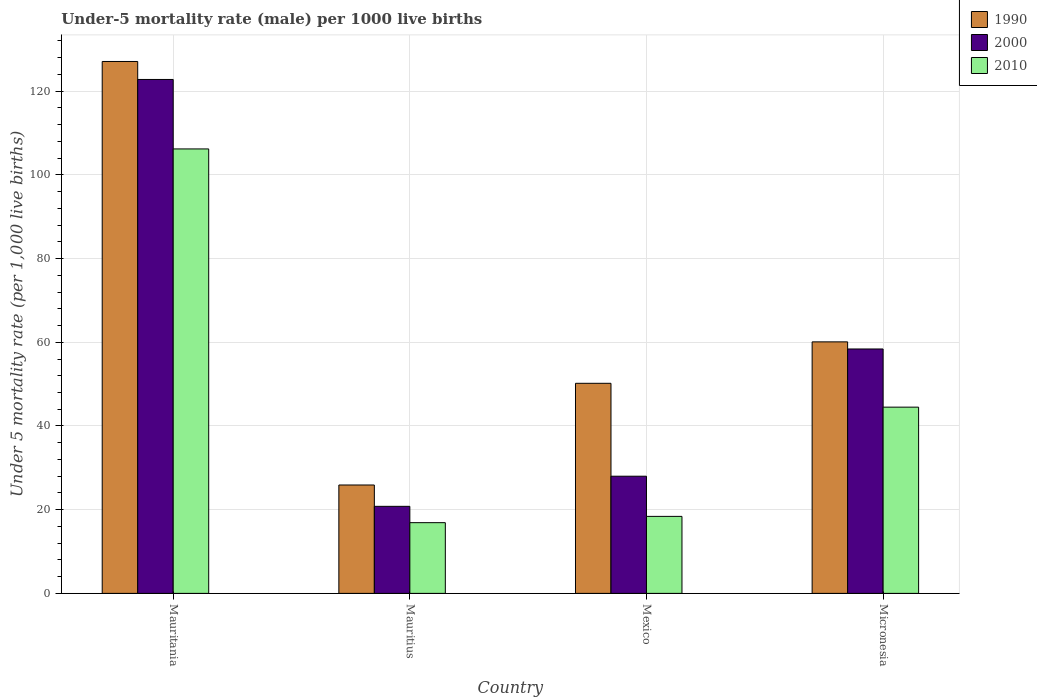Are the number of bars on each tick of the X-axis equal?
Offer a terse response. Yes. How many bars are there on the 2nd tick from the left?
Give a very brief answer. 3. How many bars are there on the 2nd tick from the right?
Ensure brevity in your answer.  3. What is the label of the 4th group of bars from the left?
Your answer should be very brief. Micronesia. In how many cases, is the number of bars for a given country not equal to the number of legend labels?
Provide a succinct answer. 0. What is the under-five mortality rate in 2000 in Micronesia?
Keep it short and to the point. 58.4. Across all countries, what is the maximum under-five mortality rate in 1990?
Offer a terse response. 127.1. Across all countries, what is the minimum under-five mortality rate in 1990?
Your response must be concise. 25.9. In which country was the under-five mortality rate in 1990 maximum?
Provide a succinct answer. Mauritania. In which country was the under-five mortality rate in 2000 minimum?
Make the answer very short. Mauritius. What is the total under-five mortality rate in 1990 in the graph?
Your answer should be very brief. 263.3. What is the difference between the under-five mortality rate in 2000 in Mauritius and that in Mexico?
Provide a succinct answer. -7.2. What is the difference between the under-five mortality rate in 1990 in Mexico and the under-five mortality rate in 2010 in Micronesia?
Provide a succinct answer. 5.7. What is the average under-five mortality rate in 2010 per country?
Give a very brief answer. 46.5. What is the difference between the under-five mortality rate of/in 2010 and under-five mortality rate of/in 1990 in Mexico?
Provide a short and direct response. -31.8. In how many countries, is the under-five mortality rate in 1990 greater than 24?
Provide a short and direct response. 4. What is the ratio of the under-five mortality rate in 2000 in Mauritania to that in Mexico?
Keep it short and to the point. 4.39. What is the difference between the highest and the second highest under-five mortality rate in 2010?
Keep it short and to the point. 87.8. What is the difference between the highest and the lowest under-five mortality rate in 2000?
Your answer should be compact. 102. Is the sum of the under-five mortality rate in 2010 in Mauritania and Mauritius greater than the maximum under-five mortality rate in 2000 across all countries?
Offer a terse response. Yes. Are all the bars in the graph horizontal?
Your response must be concise. No. Does the graph contain any zero values?
Provide a short and direct response. No. Does the graph contain grids?
Keep it short and to the point. Yes. Where does the legend appear in the graph?
Your response must be concise. Top right. How many legend labels are there?
Provide a short and direct response. 3. How are the legend labels stacked?
Your answer should be very brief. Vertical. What is the title of the graph?
Your answer should be very brief. Under-5 mortality rate (male) per 1000 live births. Does "1994" appear as one of the legend labels in the graph?
Give a very brief answer. No. What is the label or title of the Y-axis?
Give a very brief answer. Under 5 mortality rate (per 1,0 live births). What is the Under 5 mortality rate (per 1,000 live births) of 1990 in Mauritania?
Your answer should be very brief. 127.1. What is the Under 5 mortality rate (per 1,000 live births) in 2000 in Mauritania?
Offer a terse response. 122.8. What is the Under 5 mortality rate (per 1,000 live births) of 2010 in Mauritania?
Your answer should be very brief. 106.2. What is the Under 5 mortality rate (per 1,000 live births) in 1990 in Mauritius?
Your answer should be compact. 25.9. What is the Under 5 mortality rate (per 1,000 live births) in 2000 in Mauritius?
Your response must be concise. 20.8. What is the Under 5 mortality rate (per 1,000 live births) in 1990 in Mexico?
Keep it short and to the point. 50.2. What is the Under 5 mortality rate (per 1,000 live births) in 1990 in Micronesia?
Your answer should be compact. 60.1. What is the Under 5 mortality rate (per 1,000 live births) in 2000 in Micronesia?
Provide a succinct answer. 58.4. What is the Under 5 mortality rate (per 1,000 live births) in 2010 in Micronesia?
Offer a very short reply. 44.5. Across all countries, what is the maximum Under 5 mortality rate (per 1,000 live births) of 1990?
Offer a terse response. 127.1. Across all countries, what is the maximum Under 5 mortality rate (per 1,000 live births) of 2000?
Give a very brief answer. 122.8. Across all countries, what is the maximum Under 5 mortality rate (per 1,000 live births) in 2010?
Your answer should be very brief. 106.2. Across all countries, what is the minimum Under 5 mortality rate (per 1,000 live births) in 1990?
Offer a terse response. 25.9. Across all countries, what is the minimum Under 5 mortality rate (per 1,000 live births) of 2000?
Provide a succinct answer. 20.8. What is the total Under 5 mortality rate (per 1,000 live births) of 1990 in the graph?
Ensure brevity in your answer.  263.3. What is the total Under 5 mortality rate (per 1,000 live births) of 2000 in the graph?
Keep it short and to the point. 230. What is the total Under 5 mortality rate (per 1,000 live births) of 2010 in the graph?
Make the answer very short. 186. What is the difference between the Under 5 mortality rate (per 1,000 live births) of 1990 in Mauritania and that in Mauritius?
Offer a very short reply. 101.2. What is the difference between the Under 5 mortality rate (per 1,000 live births) of 2000 in Mauritania and that in Mauritius?
Provide a short and direct response. 102. What is the difference between the Under 5 mortality rate (per 1,000 live births) in 2010 in Mauritania and that in Mauritius?
Provide a succinct answer. 89.3. What is the difference between the Under 5 mortality rate (per 1,000 live births) in 1990 in Mauritania and that in Mexico?
Keep it short and to the point. 76.9. What is the difference between the Under 5 mortality rate (per 1,000 live births) of 2000 in Mauritania and that in Mexico?
Your answer should be compact. 94.8. What is the difference between the Under 5 mortality rate (per 1,000 live births) in 2010 in Mauritania and that in Mexico?
Your answer should be compact. 87.8. What is the difference between the Under 5 mortality rate (per 1,000 live births) in 1990 in Mauritania and that in Micronesia?
Your response must be concise. 67. What is the difference between the Under 5 mortality rate (per 1,000 live births) of 2000 in Mauritania and that in Micronesia?
Your response must be concise. 64.4. What is the difference between the Under 5 mortality rate (per 1,000 live births) of 2010 in Mauritania and that in Micronesia?
Make the answer very short. 61.7. What is the difference between the Under 5 mortality rate (per 1,000 live births) in 1990 in Mauritius and that in Mexico?
Provide a succinct answer. -24.3. What is the difference between the Under 5 mortality rate (per 1,000 live births) in 2000 in Mauritius and that in Mexico?
Offer a very short reply. -7.2. What is the difference between the Under 5 mortality rate (per 1,000 live births) of 2010 in Mauritius and that in Mexico?
Keep it short and to the point. -1.5. What is the difference between the Under 5 mortality rate (per 1,000 live births) in 1990 in Mauritius and that in Micronesia?
Your answer should be compact. -34.2. What is the difference between the Under 5 mortality rate (per 1,000 live births) in 2000 in Mauritius and that in Micronesia?
Ensure brevity in your answer.  -37.6. What is the difference between the Under 5 mortality rate (per 1,000 live births) of 2010 in Mauritius and that in Micronesia?
Provide a succinct answer. -27.6. What is the difference between the Under 5 mortality rate (per 1,000 live births) in 1990 in Mexico and that in Micronesia?
Make the answer very short. -9.9. What is the difference between the Under 5 mortality rate (per 1,000 live births) of 2000 in Mexico and that in Micronesia?
Ensure brevity in your answer.  -30.4. What is the difference between the Under 5 mortality rate (per 1,000 live births) of 2010 in Mexico and that in Micronesia?
Your answer should be compact. -26.1. What is the difference between the Under 5 mortality rate (per 1,000 live births) in 1990 in Mauritania and the Under 5 mortality rate (per 1,000 live births) in 2000 in Mauritius?
Your response must be concise. 106.3. What is the difference between the Under 5 mortality rate (per 1,000 live births) in 1990 in Mauritania and the Under 5 mortality rate (per 1,000 live births) in 2010 in Mauritius?
Your answer should be very brief. 110.2. What is the difference between the Under 5 mortality rate (per 1,000 live births) of 2000 in Mauritania and the Under 5 mortality rate (per 1,000 live births) of 2010 in Mauritius?
Provide a succinct answer. 105.9. What is the difference between the Under 5 mortality rate (per 1,000 live births) of 1990 in Mauritania and the Under 5 mortality rate (per 1,000 live births) of 2000 in Mexico?
Your response must be concise. 99.1. What is the difference between the Under 5 mortality rate (per 1,000 live births) in 1990 in Mauritania and the Under 5 mortality rate (per 1,000 live births) in 2010 in Mexico?
Give a very brief answer. 108.7. What is the difference between the Under 5 mortality rate (per 1,000 live births) of 2000 in Mauritania and the Under 5 mortality rate (per 1,000 live births) of 2010 in Mexico?
Your answer should be very brief. 104.4. What is the difference between the Under 5 mortality rate (per 1,000 live births) in 1990 in Mauritania and the Under 5 mortality rate (per 1,000 live births) in 2000 in Micronesia?
Ensure brevity in your answer.  68.7. What is the difference between the Under 5 mortality rate (per 1,000 live births) of 1990 in Mauritania and the Under 5 mortality rate (per 1,000 live births) of 2010 in Micronesia?
Provide a short and direct response. 82.6. What is the difference between the Under 5 mortality rate (per 1,000 live births) in 2000 in Mauritania and the Under 5 mortality rate (per 1,000 live births) in 2010 in Micronesia?
Your answer should be compact. 78.3. What is the difference between the Under 5 mortality rate (per 1,000 live births) of 2000 in Mauritius and the Under 5 mortality rate (per 1,000 live births) of 2010 in Mexico?
Give a very brief answer. 2.4. What is the difference between the Under 5 mortality rate (per 1,000 live births) in 1990 in Mauritius and the Under 5 mortality rate (per 1,000 live births) in 2000 in Micronesia?
Offer a terse response. -32.5. What is the difference between the Under 5 mortality rate (per 1,000 live births) of 1990 in Mauritius and the Under 5 mortality rate (per 1,000 live births) of 2010 in Micronesia?
Your answer should be very brief. -18.6. What is the difference between the Under 5 mortality rate (per 1,000 live births) in 2000 in Mauritius and the Under 5 mortality rate (per 1,000 live births) in 2010 in Micronesia?
Give a very brief answer. -23.7. What is the difference between the Under 5 mortality rate (per 1,000 live births) of 2000 in Mexico and the Under 5 mortality rate (per 1,000 live births) of 2010 in Micronesia?
Give a very brief answer. -16.5. What is the average Under 5 mortality rate (per 1,000 live births) of 1990 per country?
Offer a terse response. 65.83. What is the average Under 5 mortality rate (per 1,000 live births) in 2000 per country?
Keep it short and to the point. 57.5. What is the average Under 5 mortality rate (per 1,000 live births) in 2010 per country?
Provide a short and direct response. 46.5. What is the difference between the Under 5 mortality rate (per 1,000 live births) of 1990 and Under 5 mortality rate (per 1,000 live births) of 2000 in Mauritania?
Provide a succinct answer. 4.3. What is the difference between the Under 5 mortality rate (per 1,000 live births) in 1990 and Under 5 mortality rate (per 1,000 live births) in 2010 in Mauritania?
Keep it short and to the point. 20.9. What is the difference between the Under 5 mortality rate (per 1,000 live births) of 2000 and Under 5 mortality rate (per 1,000 live births) of 2010 in Mauritania?
Your answer should be compact. 16.6. What is the difference between the Under 5 mortality rate (per 1,000 live births) in 1990 and Under 5 mortality rate (per 1,000 live births) in 2010 in Mauritius?
Give a very brief answer. 9. What is the difference between the Under 5 mortality rate (per 1,000 live births) of 1990 and Under 5 mortality rate (per 1,000 live births) of 2000 in Mexico?
Your response must be concise. 22.2. What is the difference between the Under 5 mortality rate (per 1,000 live births) in 1990 and Under 5 mortality rate (per 1,000 live births) in 2010 in Mexico?
Provide a short and direct response. 31.8. What is the difference between the Under 5 mortality rate (per 1,000 live births) in 1990 and Under 5 mortality rate (per 1,000 live births) in 2000 in Micronesia?
Give a very brief answer. 1.7. What is the difference between the Under 5 mortality rate (per 1,000 live births) in 1990 and Under 5 mortality rate (per 1,000 live births) in 2010 in Micronesia?
Keep it short and to the point. 15.6. What is the ratio of the Under 5 mortality rate (per 1,000 live births) in 1990 in Mauritania to that in Mauritius?
Provide a short and direct response. 4.91. What is the ratio of the Under 5 mortality rate (per 1,000 live births) in 2000 in Mauritania to that in Mauritius?
Provide a short and direct response. 5.9. What is the ratio of the Under 5 mortality rate (per 1,000 live births) in 2010 in Mauritania to that in Mauritius?
Your answer should be very brief. 6.28. What is the ratio of the Under 5 mortality rate (per 1,000 live births) in 1990 in Mauritania to that in Mexico?
Make the answer very short. 2.53. What is the ratio of the Under 5 mortality rate (per 1,000 live births) of 2000 in Mauritania to that in Mexico?
Provide a short and direct response. 4.39. What is the ratio of the Under 5 mortality rate (per 1,000 live births) in 2010 in Mauritania to that in Mexico?
Keep it short and to the point. 5.77. What is the ratio of the Under 5 mortality rate (per 1,000 live births) of 1990 in Mauritania to that in Micronesia?
Your answer should be very brief. 2.11. What is the ratio of the Under 5 mortality rate (per 1,000 live births) of 2000 in Mauritania to that in Micronesia?
Offer a terse response. 2.1. What is the ratio of the Under 5 mortality rate (per 1,000 live births) of 2010 in Mauritania to that in Micronesia?
Your answer should be compact. 2.39. What is the ratio of the Under 5 mortality rate (per 1,000 live births) of 1990 in Mauritius to that in Mexico?
Keep it short and to the point. 0.52. What is the ratio of the Under 5 mortality rate (per 1,000 live births) in 2000 in Mauritius to that in Mexico?
Your answer should be compact. 0.74. What is the ratio of the Under 5 mortality rate (per 1,000 live births) of 2010 in Mauritius to that in Mexico?
Your response must be concise. 0.92. What is the ratio of the Under 5 mortality rate (per 1,000 live births) in 1990 in Mauritius to that in Micronesia?
Provide a short and direct response. 0.43. What is the ratio of the Under 5 mortality rate (per 1,000 live births) in 2000 in Mauritius to that in Micronesia?
Keep it short and to the point. 0.36. What is the ratio of the Under 5 mortality rate (per 1,000 live births) of 2010 in Mauritius to that in Micronesia?
Keep it short and to the point. 0.38. What is the ratio of the Under 5 mortality rate (per 1,000 live births) in 1990 in Mexico to that in Micronesia?
Offer a very short reply. 0.84. What is the ratio of the Under 5 mortality rate (per 1,000 live births) in 2000 in Mexico to that in Micronesia?
Your response must be concise. 0.48. What is the ratio of the Under 5 mortality rate (per 1,000 live births) of 2010 in Mexico to that in Micronesia?
Offer a very short reply. 0.41. What is the difference between the highest and the second highest Under 5 mortality rate (per 1,000 live births) in 1990?
Ensure brevity in your answer.  67. What is the difference between the highest and the second highest Under 5 mortality rate (per 1,000 live births) in 2000?
Keep it short and to the point. 64.4. What is the difference between the highest and the second highest Under 5 mortality rate (per 1,000 live births) in 2010?
Offer a terse response. 61.7. What is the difference between the highest and the lowest Under 5 mortality rate (per 1,000 live births) of 1990?
Give a very brief answer. 101.2. What is the difference between the highest and the lowest Under 5 mortality rate (per 1,000 live births) of 2000?
Offer a terse response. 102. What is the difference between the highest and the lowest Under 5 mortality rate (per 1,000 live births) in 2010?
Provide a short and direct response. 89.3. 